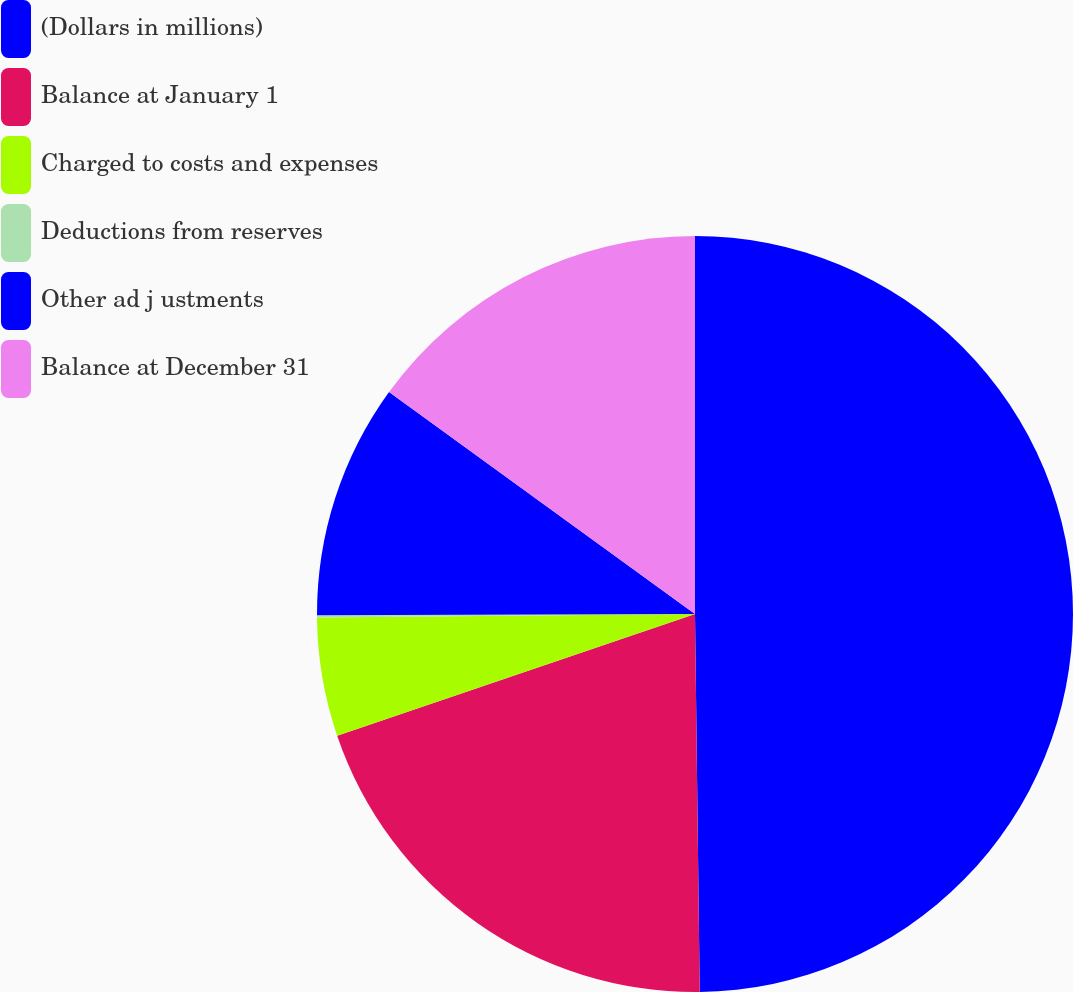<chart> <loc_0><loc_0><loc_500><loc_500><pie_chart><fcel>(Dollars in millions)<fcel>Balance at January 1<fcel>Charged to costs and expenses<fcel>Deductions from reserves<fcel>Other ad j ustments<fcel>Balance at December 31<nl><fcel>49.8%<fcel>19.98%<fcel>5.07%<fcel>0.1%<fcel>10.04%<fcel>15.01%<nl></chart> 